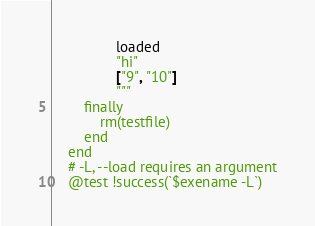<code> <loc_0><loc_0><loc_500><loc_500><_Julia_>                loaded
                "hi"
                ["9", "10"]
                """
        finally
            rm(testfile)
        end
    end
    # -L, --load requires an argument
    @test !success(`$exename -L`)</code> 